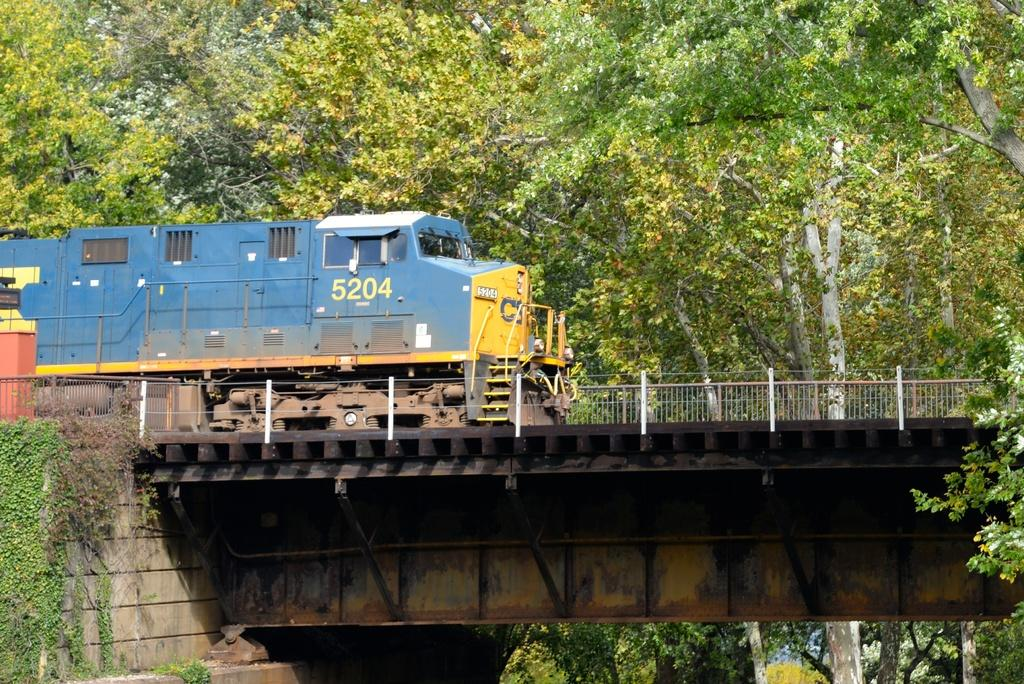<image>
Share a concise interpretation of the image provided. A train going over a bridge, it has the number 5204 in yellow on the front. 